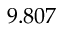Convert formula to latex. <formula><loc_0><loc_0><loc_500><loc_500>9 . 8 0 7</formula> 